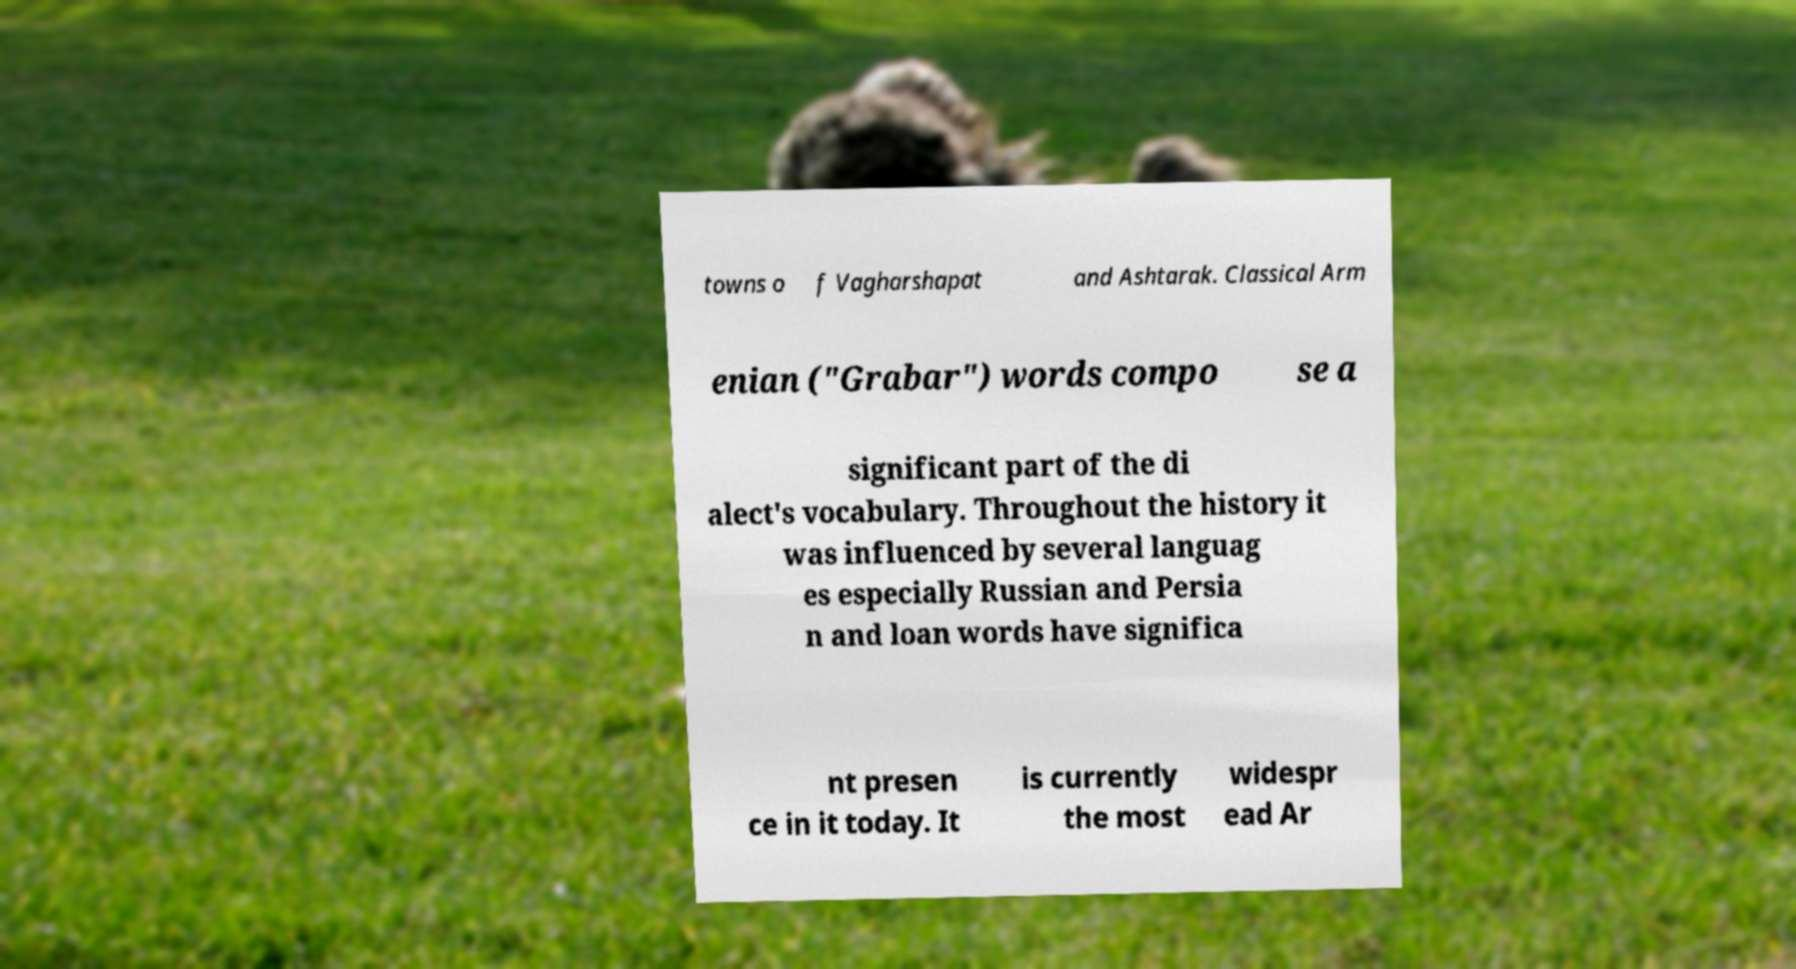Could you extract and type out the text from this image? towns o f Vagharshapat and Ashtarak. Classical Arm enian ("Grabar") words compo se a significant part of the di alect's vocabulary. Throughout the history it was influenced by several languag es especially Russian and Persia n and loan words have significa nt presen ce in it today. It is currently the most widespr ead Ar 